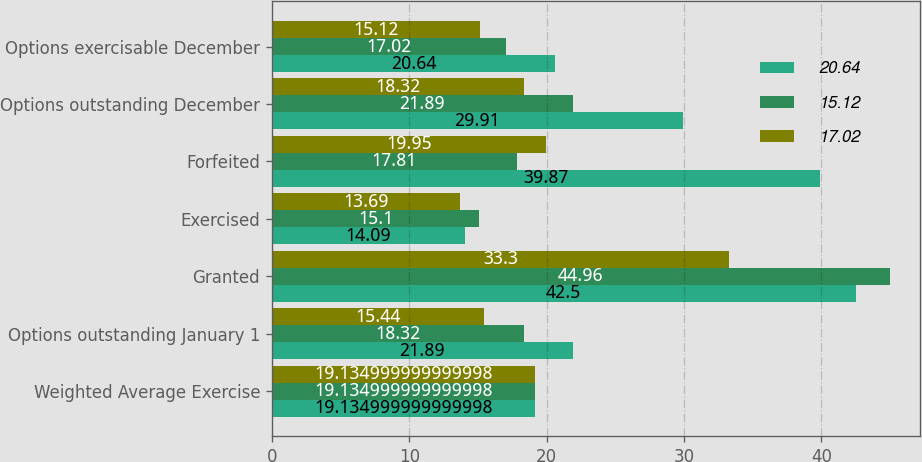Convert chart to OTSL. <chart><loc_0><loc_0><loc_500><loc_500><stacked_bar_chart><ecel><fcel>Weighted Average Exercise<fcel>Options outstanding January 1<fcel>Granted<fcel>Exercised<fcel>Forfeited<fcel>Options outstanding December<fcel>Options exercisable December<nl><fcel>20.64<fcel>19.135<fcel>21.89<fcel>42.5<fcel>14.09<fcel>39.87<fcel>29.91<fcel>20.64<nl><fcel>15.12<fcel>19.135<fcel>18.32<fcel>44.96<fcel>15.1<fcel>17.81<fcel>21.89<fcel>17.02<nl><fcel>17.02<fcel>19.135<fcel>15.44<fcel>33.3<fcel>13.69<fcel>19.95<fcel>18.32<fcel>15.12<nl></chart> 